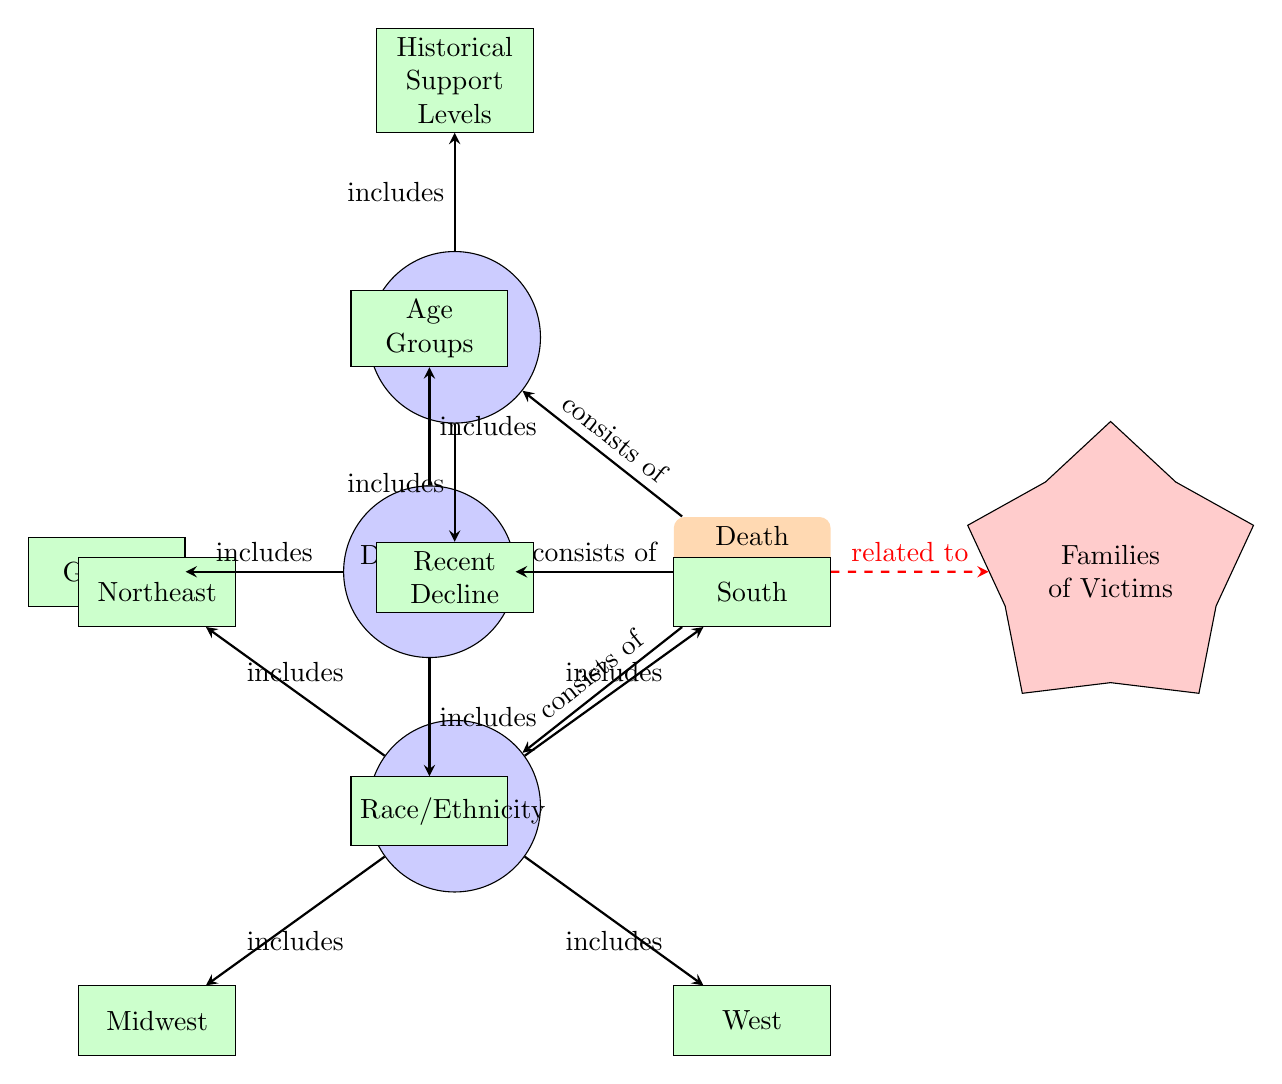What is the central topic of the diagram? The central node of the diagram is labeled "Death Penalty Support," indicating that the main focus of the diagram is on public opinion regarding support for the death penalty.
Answer: Death Penalty Support How many main categories are connected to the central topic? The central node "Death Penalty Support" connects to three primary categories: "Overall Trends," "Demographic Data," and "Regional Data." This shows that there are three main categories related to the topic.
Answer: 3 What consists of the "Overall Trends" category? The "Overall Trends" category is further divided into two subcategories: "Historical Support Levels" and "Recent Decline," indicating that this category consists of these two aspects.
Answer: Historical Support Levels, Recent Decline What demographic aspect is represented as being included in the "Demographic Data" category? The "Demographic Data" category includes three subcategories: "Age Groups," "Gender," and "Race/Ethnicity," showing that these aspects are part of the demographic data examined in relation to death penalty support.
Answer: Age Groups, Gender, Race/Ethnicity Which regional subcategory is located in the bottom left of the "Regional Data" category? In the "Regional Data" category, the subcategory "Midwest" is positioned in the bottom left, indicating its location within this section of the diagram.
Answer: Midwest What is the relationship between “Death Penalty Support” and “Families of Victims”? The diagram shows a dashed red line connecting "Death Penalty Support" to "Families of Victims," indicating a related but distinct perspective, suggesting that the views on the death penalty may be influenced by the experience of families of victims.
Answer: related to How does the diagram depict the representation of regional attitudes towards the death penalty? The diagram categorizes regional attitudes into four specific subcategories (Northeast, South, Midwest, West) under "Regional Data," suggesting that public opinion on the death penalty varies significantly by region.
Answer: varies by region What are the two main aspects included in "Overall Trends"? The two main aspects included in "Overall Trends" are "Historical Support Levels" and "Recent Decline," indicating how public opinion has changed over time.
Answer: Historical Support Levels, Recent Decline How does the structure of the diagram help in understanding public opinion? The diagram's structured layout, connecting the central topic with detailed categories and subcategories, allows for a clear understanding of the multiple factors that influence public opinion on the death penalty.
Answer: clear understanding 